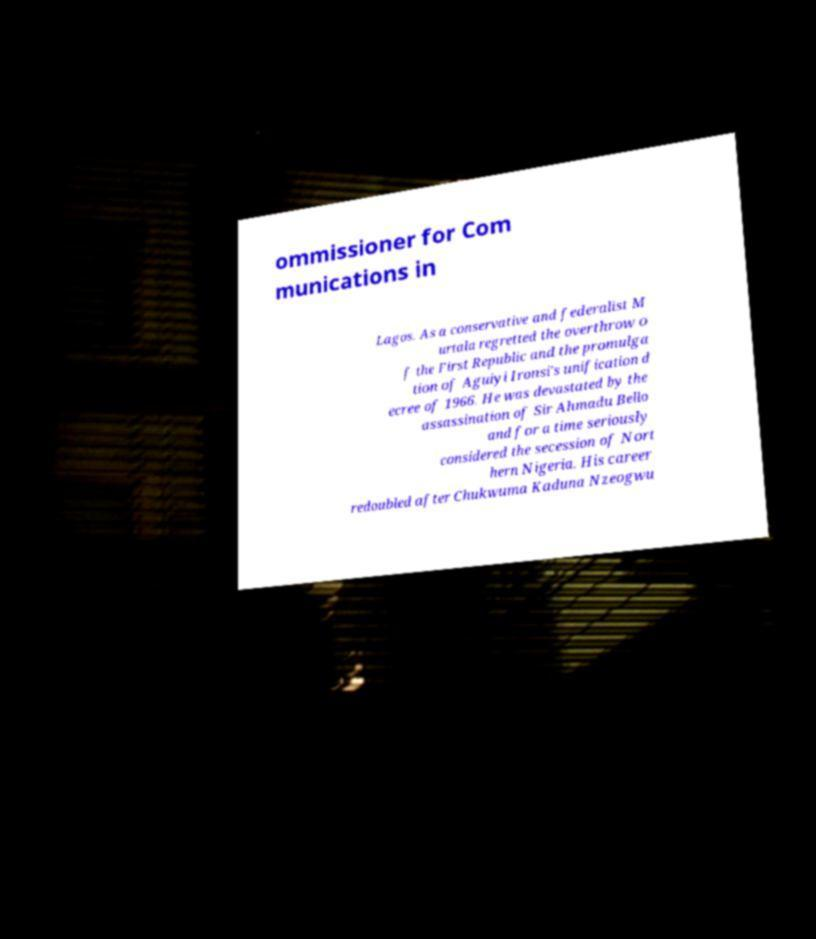Can you accurately transcribe the text from the provided image for me? ommissioner for Com munications in Lagos. As a conservative and federalist M urtala regretted the overthrow o f the First Republic and the promulga tion of Aguiyi Ironsi's unification d ecree of 1966. He was devastated by the assassination of Sir Ahmadu Bello and for a time seriously considered the secession of Nort hern Nigeria. His career redoubled after Chukwuma Kaduna Nzeogwu 